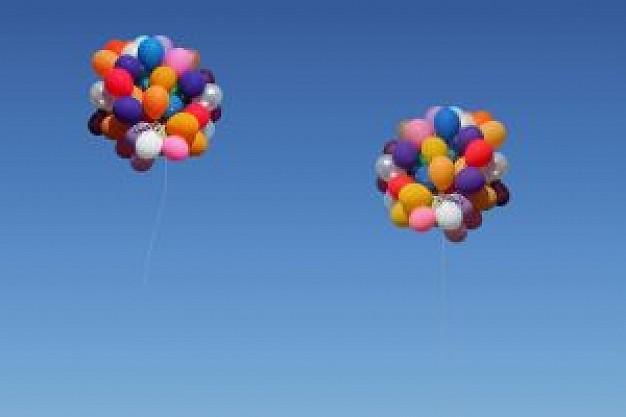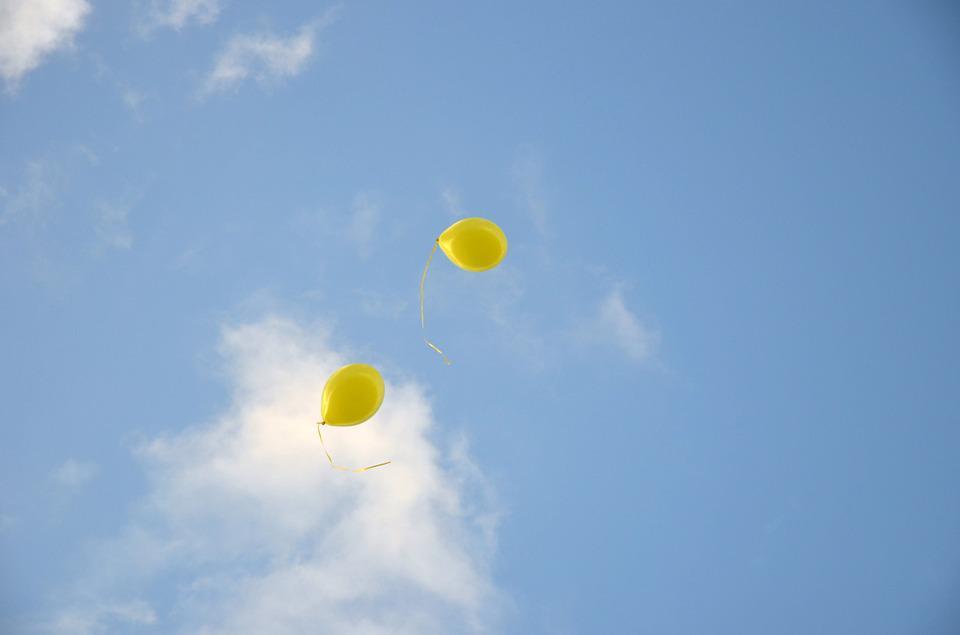The first image is the image on the left, the second image is the image on the right. For the images displayed, is the sentence "An image contains exactly two yellowish balloons against a cloud-scattered blue sky." factually correct? Answer yes or no. Yes. The first image is the image on the left, the second image is the image on the right. For the images shown, is this caption "In at least one of the pictures, all of the balloons are yellow." true? Answer yes or no. Yes. 